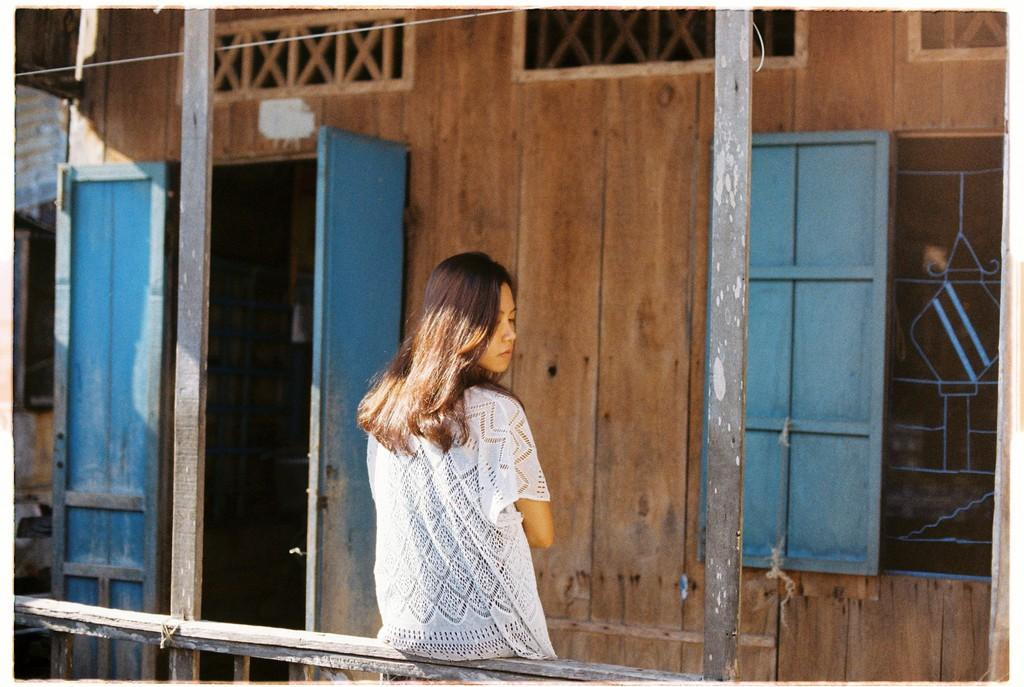Who is present in the image? There is a woman in the image. Where is the woman located in relation to the wooden fencing? The woman is standing near to the wooden fencing. What is in front of the woman? There is a wooden wall in front of the woman. What architectural features can be seen on the sides of the image? There is a window on the right side of the image and a door on the left side of the image. What type of clock can be seen hanging on the wall in the image? There is no clock visible in the image. Can you describe the rabbit that is sitting next to the woman in the image? There is no rabbit present in the image. 